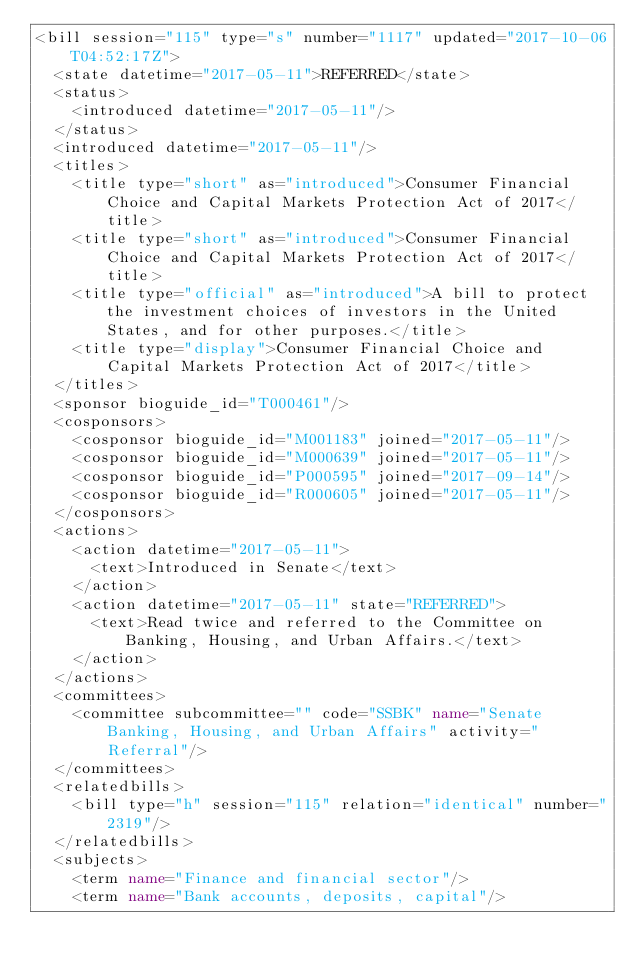<code> <loc_0><loc_0><loc_500><loc_500><_XML_><bill session="115" type="s" number="1117" updated="2017-10-06T04:52:17Z">
  <state datetime="2017-05-11">REFERRED</state>
  <status>
    <introduced datetime="2017-05-11"/>
  </status>
  <introduced datetime="2017-05-11"/>
  <titles>
    <title type="short" as="introduced">Consumer Financial Choice and Capital Markets Protection Act of 2017</title>
    <title type="short" as="introduced">Consumer Financial Choice and Capital Markets Protection Act of 2017</title>
    <title type="official" as="introduced">A bill to protect the investment choices of investors in the United States, and for other purposes.</title>
    <title type="display">Consumer Financial Choice and Capital Markets Protection Act of 2017</title>
  </titles>
  <sponsor bioguide_id="T000461"/>
  <cosponsors>
    <cosponsor bioguide_id="M001183" joined="2017-05-11"/>
    <cosponsor bioguide_id="M000639" joined="2017-05-11"/>
    <cosponsor bioguide_id="P000595" joined="2017-09-14"/>
    <cosponsor bioguide_id="R000605" joined="2017-05-11"/>
  </cosponsors>
  <actions>
    <action datetime="2017-05-11">
      <text>Introduced in Senate</text>
    </action>
    <action datetime="2017-05-11" state="REFERRED">
      <text>Read twice and referred to the Committee on Banking, Housing, and Urban Affairs.</text>
    </action>
  </actions>
  <committees>
    <committee subcommittee="" code="SSBK" name="Senate Banking, Housing, and Urban Affairs" activity="Referral"/>
  </committees>
  <relatedbills>
    <bill type="h" session="115" relation="identical" number="2319"/>
  </relatedbills>
  <subjects>
    <term name="Finance and financial sector"/>
    <term name="Bank accounts, deposits, capital"/></code> 